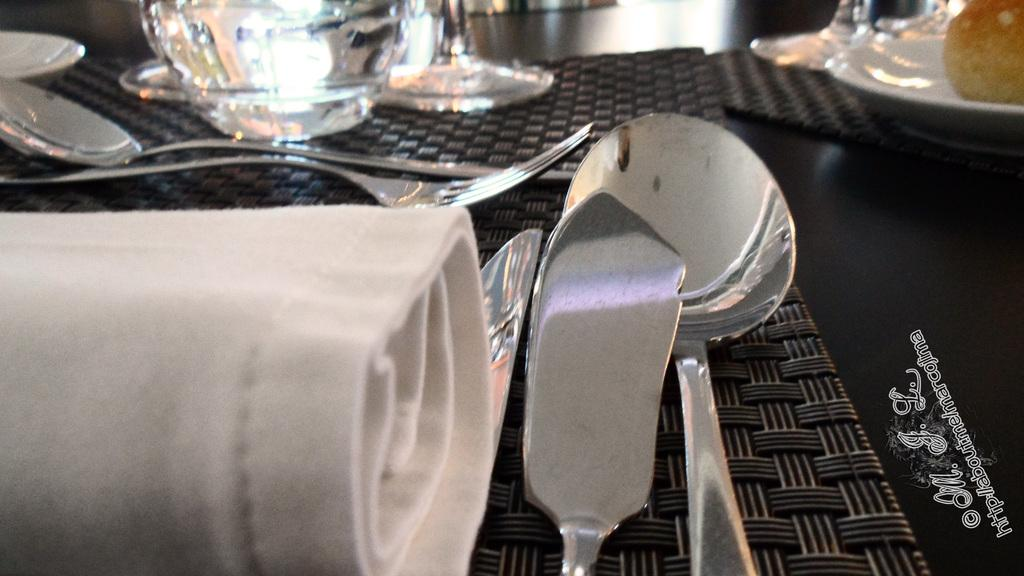What type of utensils can be seen in the image? There are spoons, a knife, and forks in the image. What type of dishware is present in the image? There are bowls in the image. Where are these objects located? All of these objects are on a table. What type of grass is growing on the table in the image? There is no grass present in the image; the objects are on a table without any vegetation. 